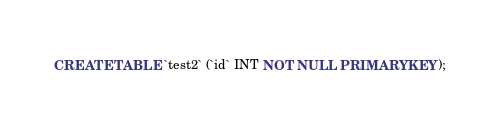<code> <loc_0><loc_0><loc_500><loc_500><_SQL_>CREATE TABLE `test2` (`id` INT NOT NULL PRIMARY KEY);</code> 